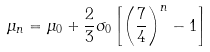Convert formula to latex. <formula><loc_0><loc_0><loc_500><loc_500>\mu _ { n } = \mu _ { 0 } + \frac { 2 } { 3 } \sigma _ { 0 } \left [ \left ( \frac { 7 } { 4 } \right ) ^ { n } - 1 \right ]</formula> 